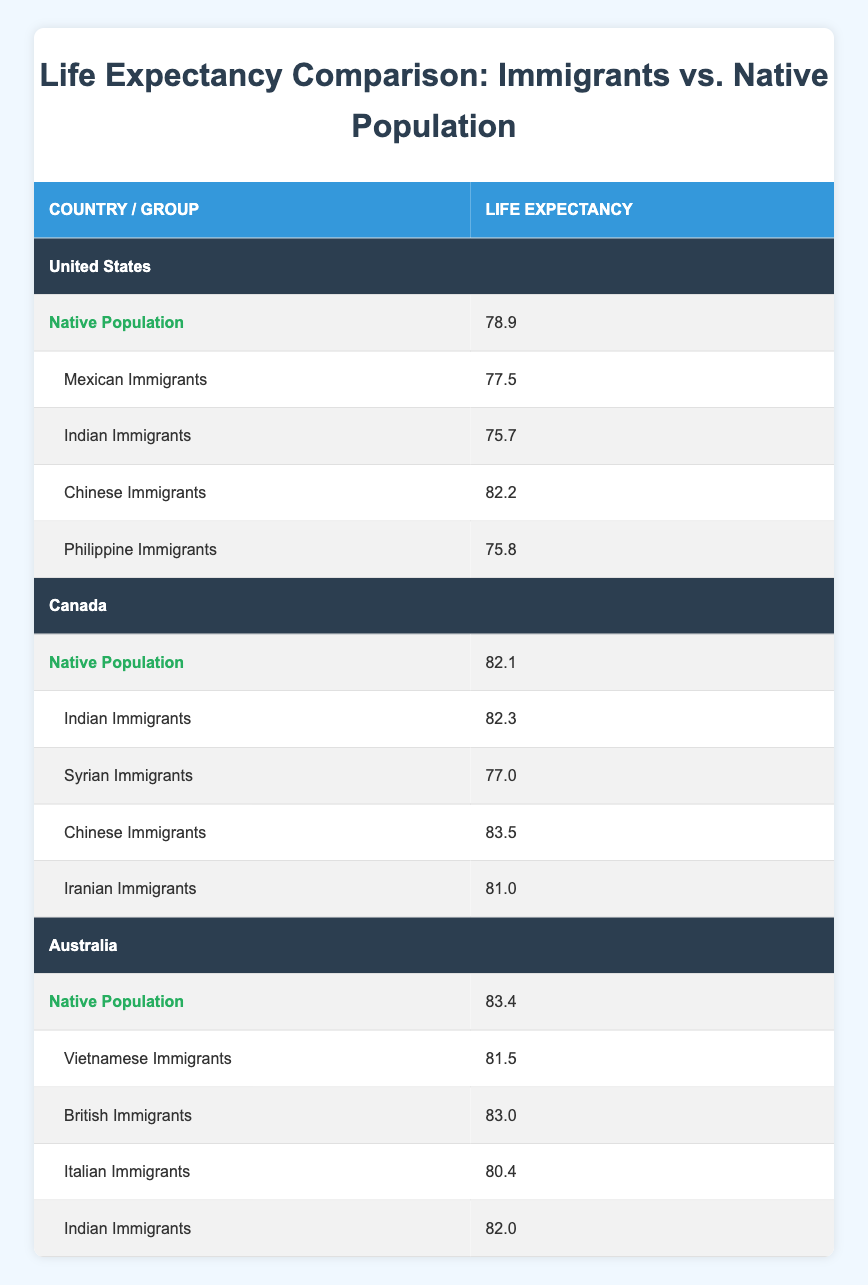What is the life expectancy of the native population in the United States? Referring to the table, the life expectancy of the native population in the United States is listed as 78.9.
Answer: 78.9 Which immigrant group in Canada has the highest life expectancy? In Canada, the life expectancy of the immigrant groups is 82.3 for Indian immigrants, 77.0 for Syrian immigrants, 83.5 for Chinese immigrants, and 81.0 for Iranian immigrants. The highest among these is 83.5 for Chinese immigrants.
Answer: 83.5 What is the difference in life expectancy between the native population in Australia and the Mexican immigrant group in the United States? The life expectancy of the native population in Australia is 83.4 and for the Mexican immigrant group in the United States is 77.5. The difference is 83.4 - 77.5 = 5.9.
Answer: 5.9 Are Indian immigrants in Australia expected to live longer than the native Australian population? The life expectancy of Indian immigrants in Australia is 82.0, while the native population's life expectancy is 83.4. Since 82.0 is less than 83.4, the answer is no.
Answer: No What is the average life expectancy of all immigrant groups in the United States? In the United States, the life expectancies of immigrant groups are 77.5 (Mexican), 75.7 (Indian), 82.2 (Chinese), and 75.8 (Philippine). Adding these values gives 311.2, and dividing by 4 gives an average life expectancy of 77.8.
Answer: 77.8 Which immigrant group has the lowest life expectancy in the provided countries? Among all immigrant groups listed, Indian immigrants in the United States have the lowest life expectancy at 75.7.
Answer: 75.7 How many years less do Indian immigrants in the United States live compared to the native population in Canada? The life expectancy of Indian immigrants in the United States is 75.7, while the native population in Canada is 82.1. The difference is 82.1 - 75.7 = 6.4 years.
Answer: 6.4 Is the life expectancy of the Philippine immigrants higher than that of the Syrian immigrants in Canada? The life expectancy for Philippine immigrants in the United States is 75.8, and for Syrian immigrants in Canada, it is 77.0. Since 75.8 is less than 77.0, the answer is no.
Answer: No 